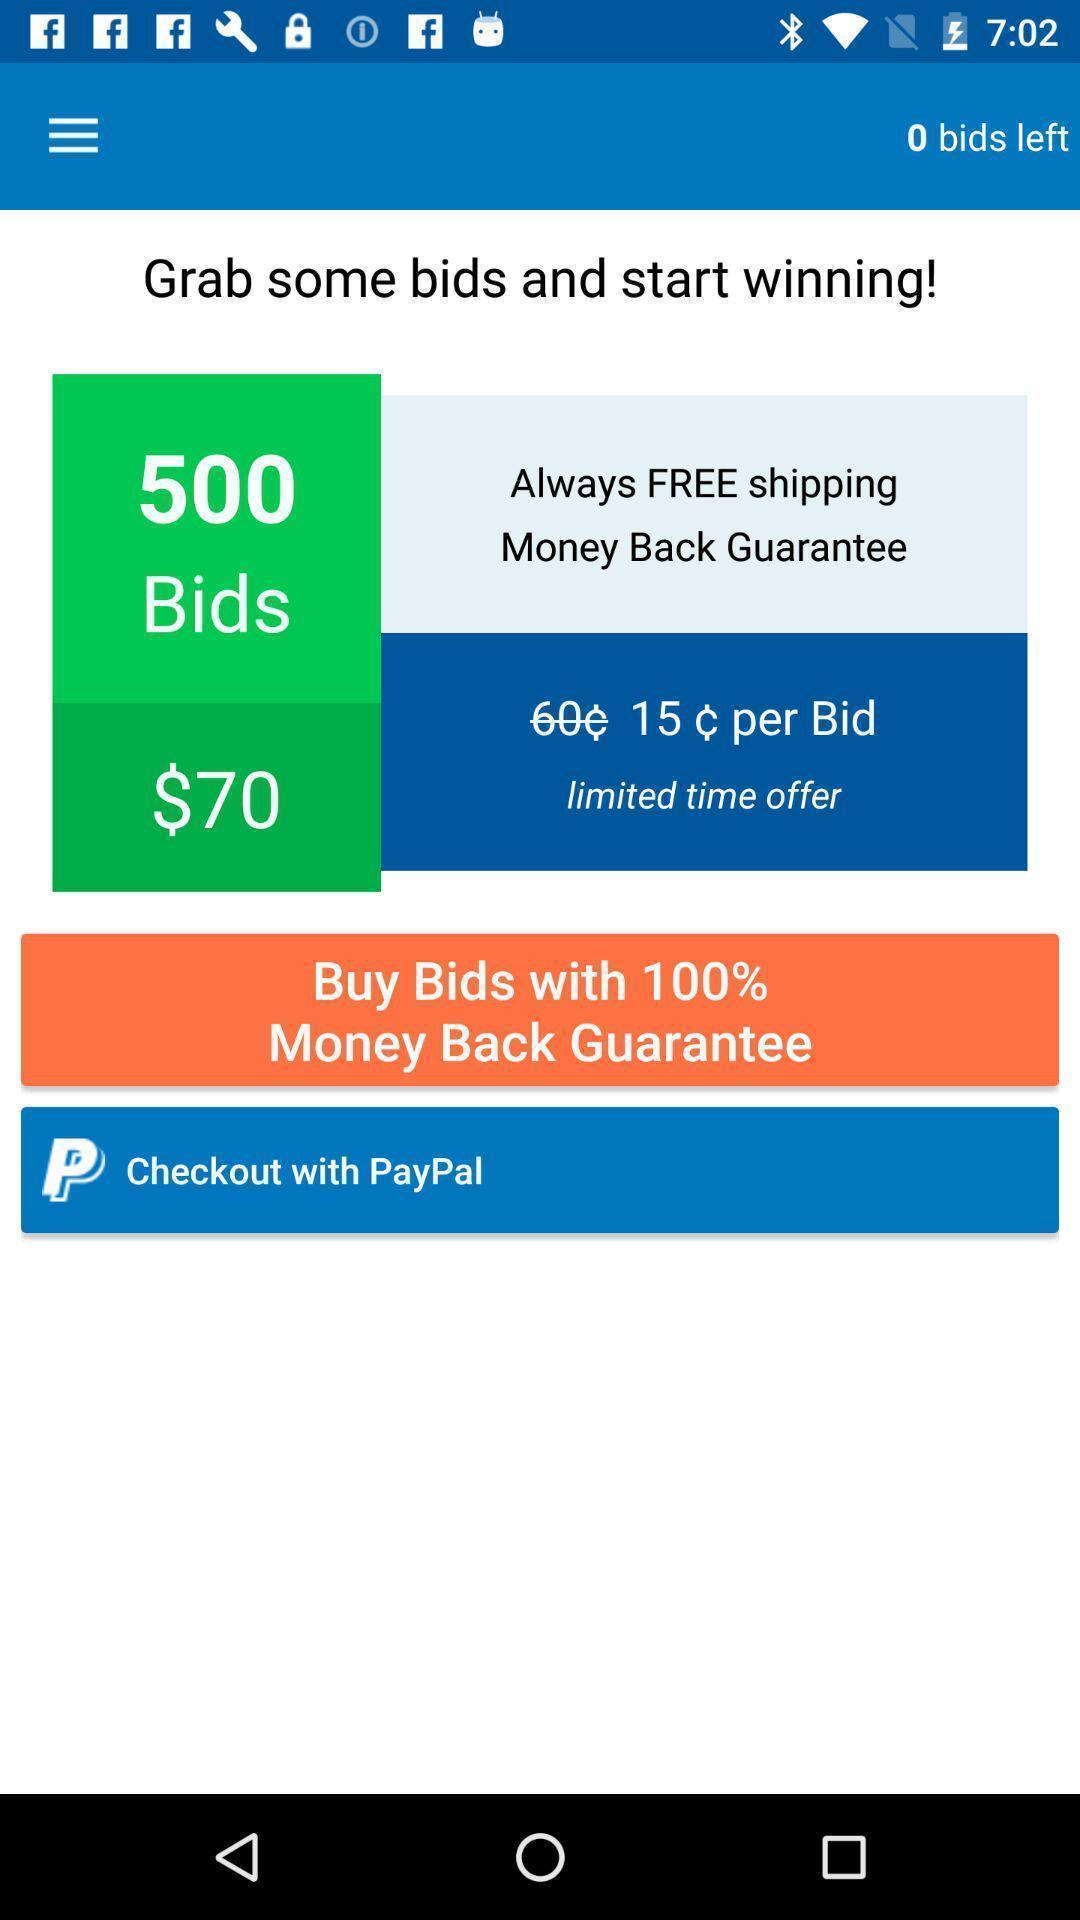Explain the elements present in this screenshot. Socialapp for showing list of bids. 